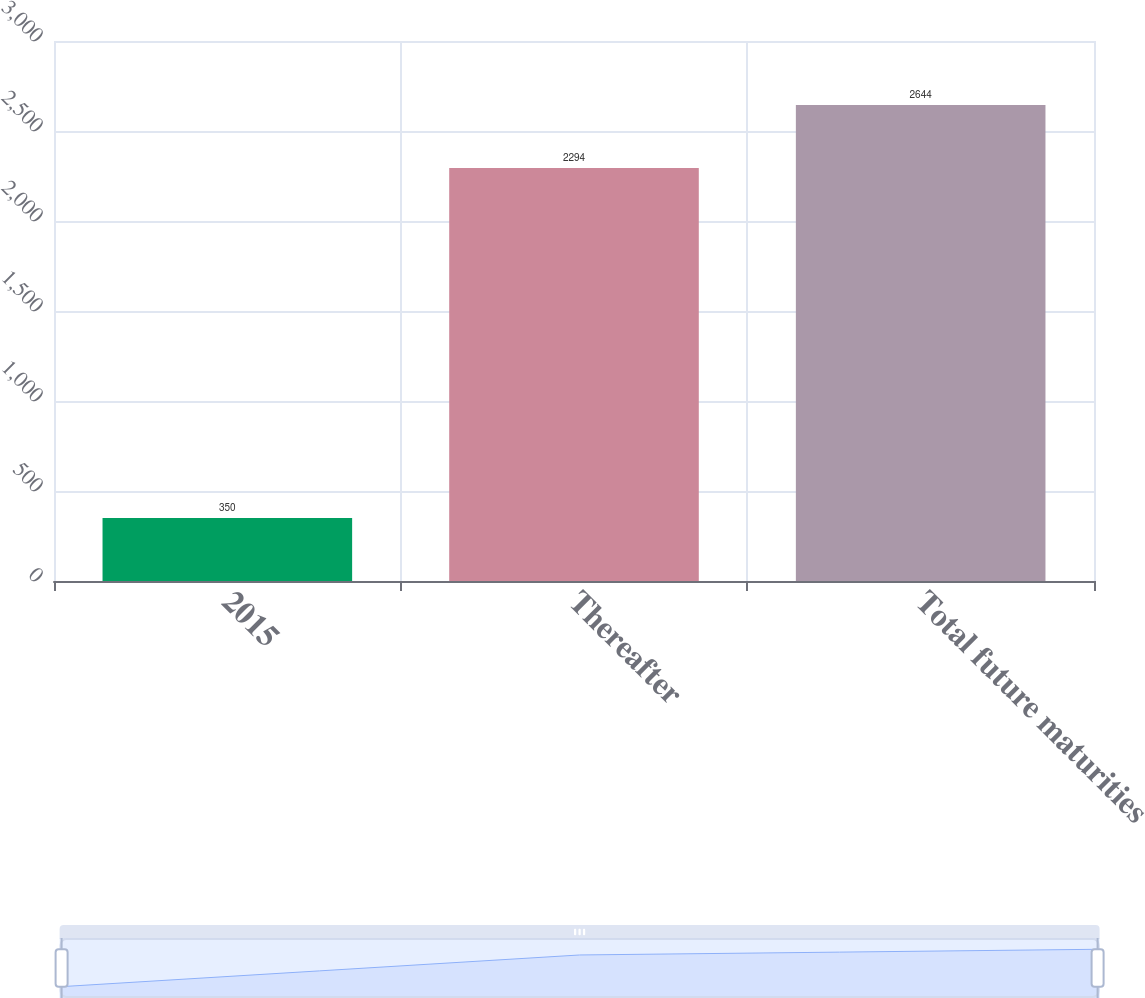Convert chart to OTSL. <chart><loc_0><loc_0><loc_500><loc_500><bar_chart><fcel>2015<fcel>Thereafter<fcel>Total future maturities<nl><fcel>350<fcel>2294<fcel>2644<nl></chart> 